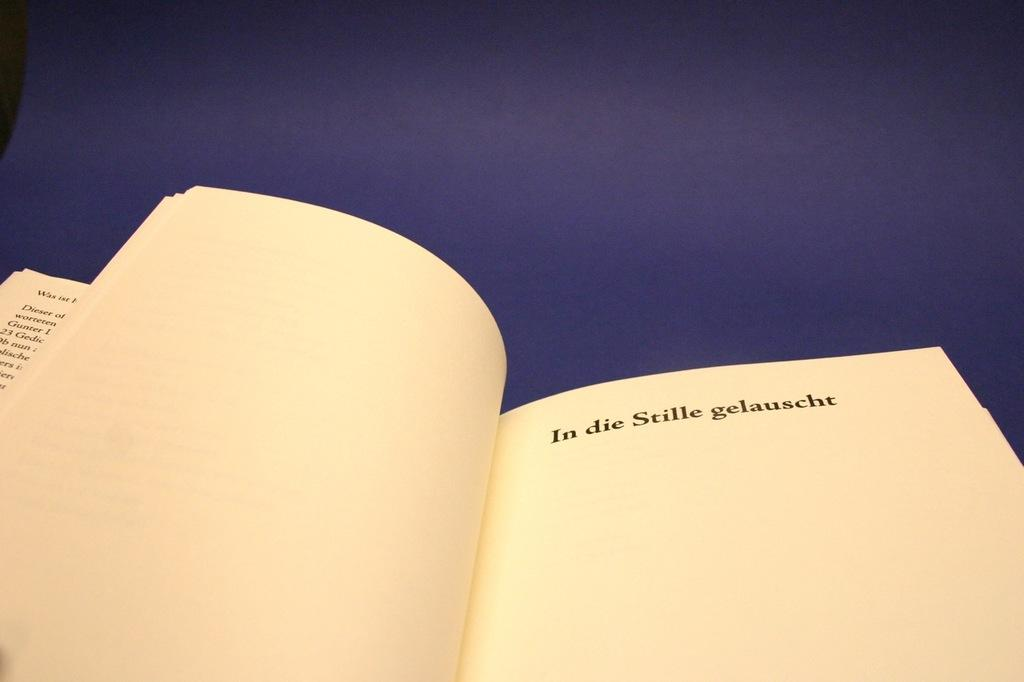<image>
Provide a brief description of the given image. A book is open with the words "In die Stille gelauscht" bolded at the top of the page. 